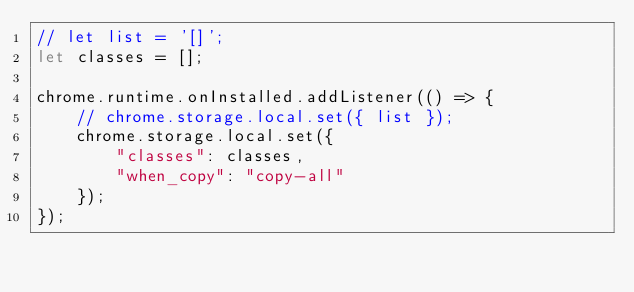<code> <loc_0><loc_0><loc_500><loc_500><_JavaScript_>// let list = '[]';
let classes = [];

chrome.runtime.onInstalled.addListener(() => {
    // chrome.storage.local.set({ list });
    chrome.storage.local.set({
        "classes": classes,
        "when_copy": "copy-all"
    });
});</code> 